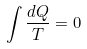Convert formula to latex. <formula><loc_0><loc_0><loc_500><loc_500>\int \frac { d Q } { T } = 0</formula> 